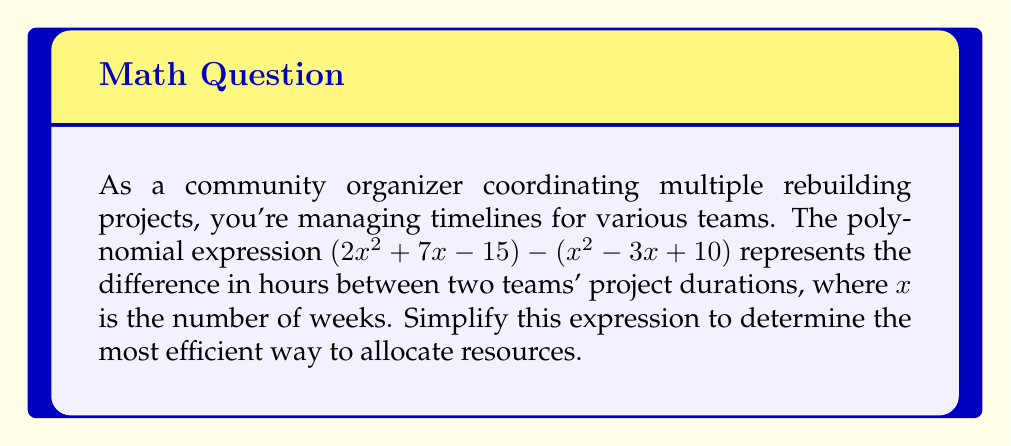Solve this math problem. To simplify this polynomial expression, we need to subtract the second polynomial from the first. Let's break it down step-by-step:

1) First, let's identify the terms in each polynomial:
   $(2x^2 + 7x - 15)$ - $(x^2 - 3x + 10)$

2) When subtracting polynomials, we subtract the corresponding terms. Remember that subtracting a positive term is the same as adding its negative:
   $2x^2 + 7x - 15 - x^2 + 3x - 10$

3) Now, let's rearrange the terms, grouping like terms together:
   $(2x^2 - x^2) + (7x + 3x) + (-15 - 10)$

4) Simplify each group:
   - For $x^2$ terms: $2x^2 - x^2 = x^2$
   - For $x$ terms: $7x + 3x = 10x$
   - For constant terms: $-15 - 10 = -25$

5) Combine the simplified terms:
   $x^2 + 10x - 25$

This simplified expression represents the difference in project duration between the two teams over $x$ weeks.
Answer: $x^2 + 10x - 25$ 